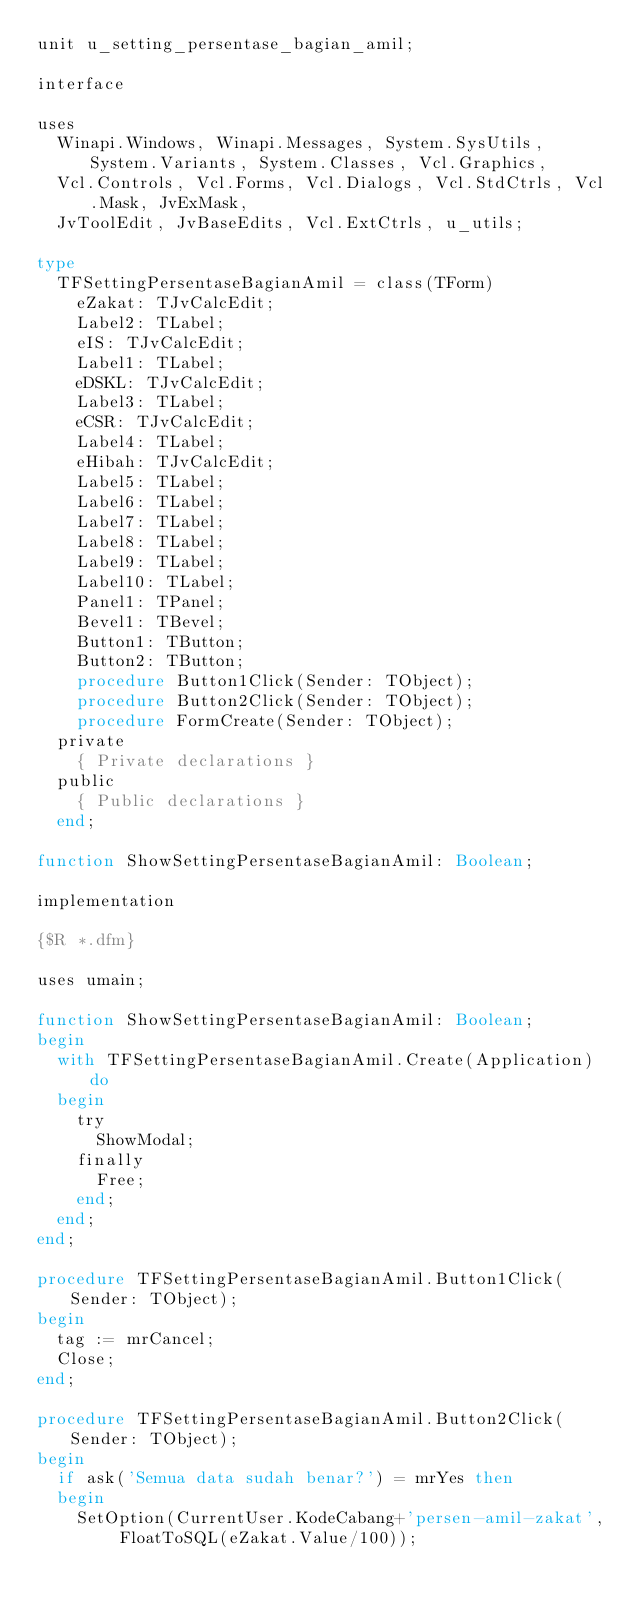Convert code to text. <code><loc_0><loc_0><loc_500><loc_500><_Pascal_>unit u_setting_persentase_bagian_amil;

interface

uses
  Winapi.Windows, Winapi.Messages, System.SysUtils, System.Variants, System.Classes, Vcl.Graphics,
  Vcl.Controls, Vcl.Forms, Vcl.Dialogs, Vcl.StdCtrls, Vcl.Mask, JvExMask,
  JvToolEdit, JvBaseEdits, Vcl.ExtCtrls, u_utils;

type
  TFSettingPersentaseBagianAmil = class(TForm)
    eZakat: TJvCalcEdit;
    Label2: TLabel;
    eIS: TJvCalcEdit;
    Label1: TLabel;
    eDSKL: TJvCalcEdit;
    Label3: TLabel;
    eCSR: TJvCalcEdit;
    Label4: TLabel;
    eHibah: TJvCalcEdit;
    Label5: TLabel;
    Label6: TLabel;
    Label7: TLabel;
    Label8: TLabel;
    Label9: TLabel;
    Label10: TLabel;
    Panel1: TPanel;
    Bevel1: TBevel;
    Button1: TButton;
    Button2: TButton;
    procedure Button1Click(Sender: TObject);
    procedure Button2Click(Sender: TObject);
    procedure FormCreate(Sender: TObject);
  private
    { Private declarations }
  public
    { Public declarations }
  end;

function ShowSettingPersentaseBagianAmil: Boolean;

implementation

{$R *.dfm}

uses umain;

function ShowSettingPersentaseBagianAmil: Boolean;
begin
  with TFSettingPersentaseBagianAmil.Create(Application) do
  begin
    try
      ShowModal;
    finally
      Free;
    end;
  end;
end;

procedure TFSettingPersentaseBagianAmil.Button1Click(Sender: TObject);
begin
  tag := mrCancel;
  Close;
end;

procedure TFSettingPersentaseBagianAmil.Button2Click(Sender: TObject);
begin
  if ask('Semua data sudah benar?') = mrYes then
  begin
    SetOption(CurrentUser.KodeCabang+'persen-amil-zakat', FloatToSQL(eZakat.Value/100));</code> 